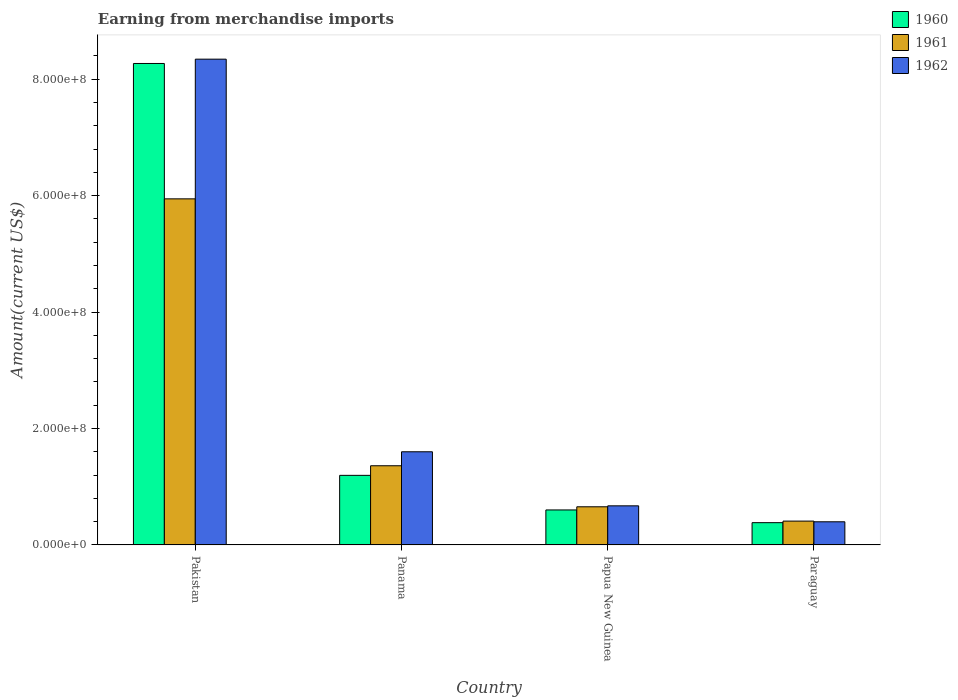How many different coloured bars are there?
Ensure brevity in your answer.  3. Are the number of bars on each tick of the X-axis equal?
Provide a succinct answer. Yes. How many bars are there on the 4th tick from the left?
Provide a succinct answer. 3. How many bars are there on the 3rd tick from the right?
Ensure brevity in your answer.  3. What is the label of the 4th group of bars from the left?
Give a very brief answer. Paraguay. What is the amount earned from merchandise imports in 1962 in Panama?
Offer a very short reply. 1.60e+08. Across all countries, what is the maximum amount earned from merchandise imports in 1961?
Your answer should be compact. 5.94e+08. Across all countries, what is the minimum amount earned from merchandise imports in 1962?
Offer a terse response. 3.97e+07. In which country was the amount earned from merchandise imports in 1961 maximum?
Offer a very short reply. Pakistan. In which country was the amount earned from merchandise imports in 1960 minimum?
Your answer should be very brief. Paraguay. What is the total amount earned from merchandise imports in 1962 in the graph?
Provide a short and direct response. 1.10e+09. What is the difference between the amount earned from merchandise imports in 1960 in Pakistan and that in Panama?
Offer a terse response. 7.07e+08. What is the difference between the amount earned from merchandise imports in 1962 in Papua New Guinea and the amount earned from merchandise imports in 1960 in Panama?
Your response must be concise. -5.24e+07. What is the average amount earned from merchandise imports in 1960 per country?
Your response must be concise. 2.61e+08. What is the difference between the amount earned from merchandise imports of/in 1961 and amount earned from merchandise imports of/in 1960 in Pakistan?
Offer a terse response. -2.33e+08. What is the ratio of the amount earned from merchandise imports in 1962 in Papua New Guinea to that in Paraguay?
Ensure brevity in your answer.  1.69. Is the amount earned from merchandise imports in 1961 in Pakistan less than that in Papua New Guinea?
Your response must be concise. No. Is the difference between the amount earned from merchandise imports in 1961 in Panama and Paraguay greater than the difference between the amount earned from merchandise imports in 1960 in Panama and Paraguay?
Your answer should be compact. Yes. What is the difference between the highest and the second highest amount earned from merchandise imports in 1962?
Provide a short and direct response. 6.74e+08. What is the difference between the highest and the lowest amount earned from merchandise imports in 1960?
Your answer should be very brief. 7.89e+08. In how many countries, is the amount earned from merchandise imports in 1960 greater than the average amount earned from merchandise imports in 1960 taken over all countries?
Offer a terse response. 1. What does the 2nd bar from the right in Panama represents?
Offer a very short reply. 1961. Is it the case that in every country, the sum of the amount earned from merchandise imports in 1960 and amount earned from merchandise imports in 1961 is greater than the amount earned from merchandise imports in 1962?
Keep it short and to the point. Yes. What is the difference between two consecutive major ticks on the Y-axis?
Give a very brief answer. 2.00e+08. Does the graph contain grids?
Offer a terse response. No. What is the title of the graph?
Your response must be concise. Earning from merchandise imports. Does "1987" appear as one of the legend labels in the graph?
Make the answer very short. No. What is the label or title of the X-axis?
Your answer should be very brief. Country. What is the label or title of the Y-axis?
Your response must be concise. Amount(current US$). What is the Amount(current US$) in 1960 in Pakistan?
Keep it short and to the point. 8.27e+08. What is the Amount(current US$) in 1961 in Pakistan?
Provide a succinct answer. 5.94e+08. What is the Amount(current US$) in 1962 in Pakistan?
Make the answer very short. 8.34e+08. What is the Amount(current US$) of 1960 in Panama?
Offer a very short reply. 1.20e+08. What is the Amount(current US$) of 1961 in Panama?
Your response must be concise. 1.36e+08. What is the Amount(current US$) in 1962 in Panama?
Provide a short and direct response. 1.60e+08. What is the Amount(current US$) in 1960 in Papua New Guinea?
Provide a succinct answer. 6.01e+07. What is the Amount(current US$) of 1961 in Papua New Guinea?
Your answer should be very brief. 6.55e+07. What is the Amount(current US$) in 1962 in Papua New Guinea?
Provide a succinct answer. 6.71e+07. What is the Amount(current US$) in 1960 in Paraguay?
Keep it short and to the point. 3.82e+07. What is the Amount(current US$) of 1961 in Paraguay?
Provide a succinct answer. 4.09e+07. What is the Amount(current US$) of 1962 in Paraguay?
Provide a short and direct response. 3.97e+07. Across all countries, what is the maximum Amount(current US$) of 1960?
Ensure brevity in your answer.  8.27e+08. Across all countries, what is the maximum Amount(current US$) of 1961?
Provide a succinct answer. 5.94e+08. Across all countries, what is the maximum Amount(current US$) in 1962?
Your answer should be compact. 8.34e+08. Across all countries, what is the minimum Amount(current US$) in 1960?
Keep it short and to the point. 3.82e+07. Across all countries, what is the minimum Amount(current US$) of 1961?
Offer a terse response. 4.09e+07. Across all countries, what is the minimum Amount(current US$) in 1962?
Your answer should be very brief. 3.97e+07. What is the total Amount(current US$) in 1960 in the graph?
Keep it short and to the point. 1.04e+09. What is the total Amount(current US$) in 1961 in the graph?
Provide a succinct answer. 8.37e+08. What is the total Amount(current US$) of 1962 in the graph?
Ensure brevity in your answer.  1.10e+09. What is the difference between the Amount(current US$) of 1960 in Pakistan and that in Panama?
Provide a succinct answer. 7.07e+08. What is the difference between the Amount(current US$) in 1961 in Pakistan and that in Panama?
Ensure brevity in your answer.  4.58e+08. What is the difference between the Amount(current US$) of 1962 in Pakistan and that in Panama?
Your answer should be very brief. 6.74e+08. What is the difference between the Amount(current US$) in 1960 in Pakistan and that in Papua New Guinea?
Your answer should be very brief. 7.67e+08. What is the difference between the Amount(current US$) of 1961 in Pakistan and that in Papua New Guinea?
Provide a succinct answer. 5.29e+08. What is the difference between the Amount(current US$) in 1962 in Pakistan and that in Papua New Guinea?
Your response must be concise. 7.67e+08. What is the difference between the Amount(current US$) of 1960 in Pakistan and that in Paraguay?
Ensure brevity in your answer.  7.89e+08. What is the difference between the Amount(current US$) of 1961 in Pakistan and that in Paraguay?
Provide a succinct answer. 5.53e+08. What is the difference between the Amount(current US$) in 1962 in Pakistan and that in Paraguay?
Make the answer very short. 7.95e+08. What is the difference between the Amount(current US$) of 1960 in Panama and that in Papua New Guinea?
Keep it short and to the point. 5.94e+07. What is the difference between the Amount(current US$) in 1961 in Panama and that in Papua New Guinea?
Offer a terse response. 7.05e+07. What is the difference between the Amount(current US$) of 1962 in Panama and that in Papua New Guinea?
Offer a terse response. 9.29e+07. What is the difference between the Amount(current US$) in 1960 in Panama and that in Paraguay?
Give a very brief answer. 8.13e+07. What is the difference between the Amount(current US$) in 1961 in Panama and that in Paraguay?
Give a very brief answer. 9.51e+07. What is the difference between the Amount(current US$) of 1962 in Panama and that in Paraguay?
Make the answer very short. 1.20e+08. What is the difference between the Amount(current US$) in 1960 in Papua New Guinea and that in Paraguay?
Offer a terse response. 2.19e+07. What is the difference between the Amount(current US$) of 1961 in Papua New Guinea and that in Paraguay?
Your answer should be very brief. 2.46e+07. What is the difference between the Amount(current US$) of 1962 in Papua New Guinea and that in Paraguay?
Provide a short and direct response. 2.74e+07. What is the difference between the Amount(current US$) of 1960 in Pakistan and the Amount(current US$) of 1961 in Panama?
Your response must be concise. 6.91e+08. What is the difference between the Amount(current US$) of 1960 in Pakistan and the Amount(current US$) of 1962 in Panama?
Give a very brief answer. 6.67e+08. What is the difference between the Amount(current US$) of 1961 in Pakistan and the Amount(current US$) of 1962 in Panama?
Provide a short and direct response. 4.34e+08. What is the difference between the Amount(current US$) of 1960 in Pakistan and the Amount(current US$) of 1961 in Papua New Guinea?
Your answer should be very brief. 7.61e+08. What is the difference between the Amount(current US$) of 1960 in Pakistan and the Amount(current US$) of 1962 in Papua New Guinea?
Make the answer very short. 7.60e+08. What is the difference between the Amount(current US$) in 1961 in Pakistan and the Amount(current US$) in 1962 in Papua New Guinea?
Offer a terse response. 5.27e+08. What is the difference between the Amount(current US$) in 1960 in Pakistan and the Amount(current US$) in 1961 in Paraguay?
Ensure brevity in your answer.  7.86e+08. What is the difference between the Amount(current US$) of 1960 in Pakistan and the Amount(current US$) of 1962 in Paraguay?
Your response must be concise. 7.87e+08. What is the difference between the Amount(current US$) in 1961 in Pakistan and the Amount(current US$) in 1962 in Paraguay?
Give a very brief answer. 5.55e+08. What is the difference between the Amount(current US$) of 1960 in Panama and the Amount(current US$) of 1961 in Papua New Guinea?
Provide a succinct answer. 5.40e+07. What is the difference between the Amount(current US$) in 1960 in Panama and the Amount(current US$) in 1962 in Papua New Guinea?
Provide a succinct answer. 5.24e+07. What is the difference between the Amount(current US$) of 1961 in Panama and the Amount(current US$) of 1962 in Papua New Guinea?
Your answer should be compact. 6.89e+07. What is the difference between the Amount(current US$) in 1960 in Panama and the Amount(current US$) in 1961 in Paraguay?
Your response must be concise. 7.86e+07. What is the difference between the Amount(current US$) in 1960 in Panama and the Amount(current US$) in 1962 in Paraguay?
Provide a succinct answer. 7.98e+07. What is the difference between the Amount(current US$) of 1961 in Panama and the Amount(current US$) of 1962 in Paraguay?
Give a very brief answer. 9.63e+07. What is the difference between the Amount(current US$) of 1960 in Papua New Guinea and the Amount(current US$) of 1961 in Paraguay?
Provide a short and direct response. 1.92e+07. What is the difference between the Amount(current US$) in 1960 in Papua New Guinea and the Amount(current US$) in 1962 in Paraguay?
Give a very brief answer. 2.04e+07. What is the difference between the Amount(current US$) of 1961 in Papua New Guinea and the Amount(current US$) of 1962 in Paraguay?
Provide a succinct answer. 2.58e+07. What is the average Amount(current US$) in 1960 per country?
Provide a short and direct response. 2.61e+08. What is the average Amount(current US$) of 1961 per country?
Provide a short and direct response. 2.09e+08. What is the average Amount(current US$) in 1962 per country?
Ensure brevity in your answer.  2.75e+08. What is the difference between the Amount(current US$) of 1960 and Amount(current US$) of 1961 in Pakistan?
Your response must be concise. 2.33e+08. What is the difference between the Amount(current US$) of 1960 and Amount(current US$) of 1962 in Pakistan?
Ensure brevity in your answer.  -7.41e+06. What is the difference between the Amount(current US$) in 1961 and Amount(current US$) in 1962 in Pakistan?
Make the answer very short. -2.40e+08. What is the difference between the Amount(current US$) in 1960 and Amount(current US$) in 1961 in Panama?
Your answer should be very brief. -1.65e+07. What is the difference between the Amount(current US$) in 1960 and Amount(current US$) in 1962 in Panama?
Your answer should be very brief. -4.05e+07. What is the difference between the Amount(current US$) in 1961 and Amount(current US$) in 1962 in Panama?
Keep it short and to the point. -2.40e+07. What is the difference between the Amount(current US$) in 1960 and Amount(current US$) in 1961 in Papua New Guinea?
Your answer should be very brief. -5.42e+06. What is the difference between the Amount(current US$) of 1960 and Amount(current US$) of 1962 in Papua New Guinea?
Ensure brevity in your answer.  -7.04e+06. What is the difference between the Amount(current US$) in 1961 and Amount(current US$) in 1962 in Papua New Guinea?
Offer a terse response. -1.62e+06. What is the difference between the Amount(current US$) in 1960 and Amount(current US$) in 1961 in Paraguay?
Ensure brevity in your answer.  -2.70e+06. What is the difference between the Amount(current US$) in 1960 and Amount(current US$) in 1962 in Paraguay?
Keep it short and to the point. -1.50e+06. What is the difference between the Amount(current US$) in 1961 and Amount(current US$) in 1962 in Paraguay?
Ensure brevity in your answer.  1.20e+06. What is the ratio of the Amount(current US$) of 1960 in Pakistan to that in Panama?
Provide a short and direct response. 6.92. What is the ratio of the Amount(current US$) in 1961 in Pakistan to that in Panama?
Provide a succinct answer. 4.37. What is the ratio of the Amount(current US$) of 1962 in Pakistan to that in Panama?
Provide a succinct answer. 5.21. What is the ratio of the Amount(current US$) of 1960 in Pakistan to that in Papua New Guinea?
Give a very brief answer. 13.76. What is the ratio of the Amount(current US$) of 1961 in Pakistan to that in Papua New Guinea?
Provide a short and direct response. 9.07. What is the ratio of the Amount(current US$) in 1962 in Pakistan to that in Papua New Guinea?
Offer a very short reply. 12.43. What is the ratio of the Amount(current US$) of 1960 in Pakistan to that in Paraguay?
Give a very brief answer. 21.62. What is the ratio of the Amount(current US$) in 1961 in Pakistan to that in Paraguay?
Offer a very short reply. 14.52. What is the ratio of the Amount(current US$) in 1962 in Pakistan to that in Paraguay?
Your response must be concise. 20.99. What is the ratio of the Amount(current US$) of 1960 in Panama to that in Papua New Guinea?
Make the answer very short. 1.99. What is the ratio of the Amount(current US$) in 1961 in Panama to that in Papua New Guinea?
Keep it short and to the point. 2.08. What is the ratio of the Amount(current US$) in 1962 in Panama to that in Papua New Guinea?
Your answer should be very brief. 2.38. What is the ratio of the Amount(current US$) of 1960 in Panama to that in Paraguay?
Give a very brief answer. 3.13. What is the ratio of the Amount(current US$) of 1961 in Panama to that in Paraguay?
Your answer should be very brief. 3.32. What is the ratio of the Amount(current US$) of 1962 in Panama to that in Paraguay?
Offer a terse response. 4.03. What is the ratio of the Amount(current US$) of 1960 in Papua New Guinea to that in Paraguay?
Give a very brief answer. 1.57. What is the ratio of the Amount(current US$) of 1961 in Papua New Guinea to that in Paraguay?
Your response must be concise. 1.6. What is the ratio of the Amount(current US$) of 1962 in Papua New Guinea to that in Paraguay?
Provide a short and direct response. 1.69. What is the difference between the highest and the second highest Amount(current US$) in 1960?
Your answer should be very brief. 7.07e+08. What is the difference between the highest and the second highest Amount(current US$) of 1961?
Ensure brevity in your answer.  4.58e+08. What is the difference between the highest and the second highest Amount(current US$) in 1962?
Your answer should be compact. 6.74e+08. What is the difference between the highest and the lowest Amount(current US$) in 1960?
Offer a very short reply. 7.89e+08. What is the difference between the highest and the lowest Amount(current US$) of 1961?
Offer a terse response. 5.53e+08. What is the difference between the highest and the lowest Amount(current US$) of 1962?
Make the answer very short. 7.95e+08. 